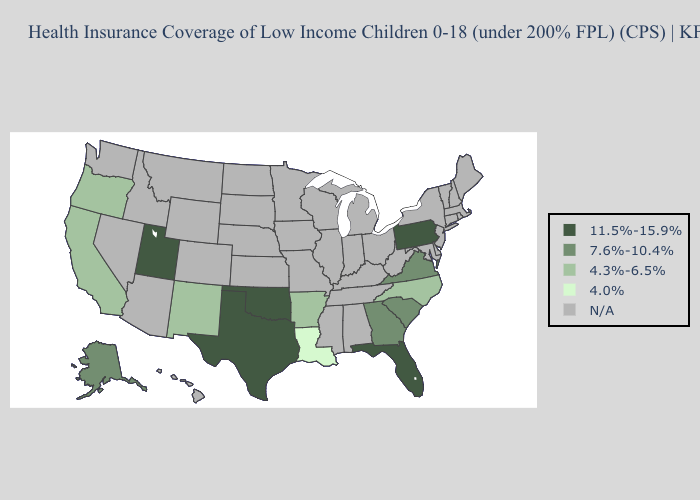Name the states that have a value in the range N/A?
Answer briefly. Alabama, Arizona, Colorado, Connecticut, Delaware, Hawaii, Idaho, Illinois, Indiana, Iowa, Kansas, Kentucky, Maine, Maryland, Massachusetts, Michigan, Minnesota, Mississippi, Missouri, Montana, Nebraska, Nevada, New Hampshire, New Jersey, New York, North Dakota, Ohio, Rhode Island, South Dakota, Tennessee, Vermont, Washington, West Virginia, Wisconsin, Wyoming. What is the highest value in the South ?
Concise answer only. 11.5%-15.9%. Name the states that have a value in the range 7.6%-10.4%?
Answer briefly. Alaska, Georgia, South Carolina, Virginia. What is the value of Georgia?
Be succinct. 7.6%-10.4%. Which states have the lowest value in the USA?
Short answer required. Louisiana. Name the states that have a value in the range 11.5%-15.9%?
Concise answer only. Florida, Oklahoma, Pennsylvania, Texas, Utah. What is the value of California?
Concise answer only. 4.3%-6.5%. Does Alaska have the highest value in the USA?
Concise answer only. No. What is the value of Maine?
Write a very short answer. N/A. Name the states that have a value in the range 7.6%-10.4%?
Keep it brief. Alaska, Georgia, South Carolina, Virginia. What is the value of Virginia?
Keep it brief. 7.6%-10.4%. Name the states that have a value in the range 7.6%-10.4%?
Write a very short answer. Alaska, Georgia, South Carolina, Virginia. What is the value of South Dakota?
Keep it brief. N/A. 